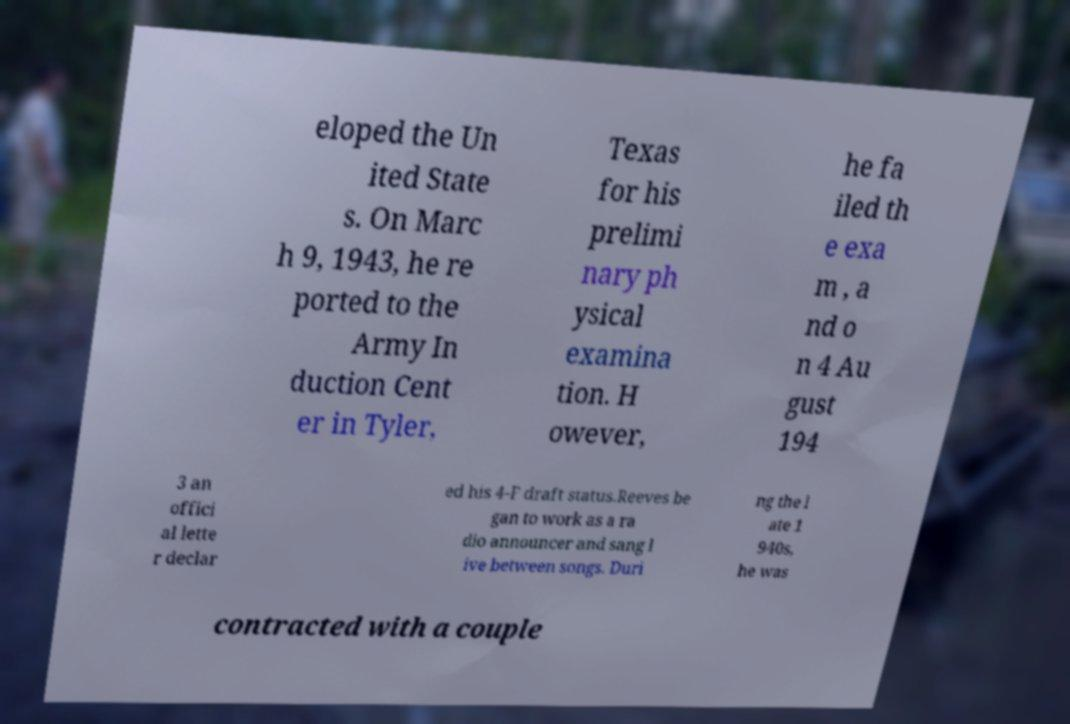I need the written content from this picture converted into text. Can you do that? eloped the Un ited State s. On Marc h 9, 1943, he re ported to the Army In duction Cent er in Tyler, Texas for his prelimi nary ph ysical examina tion. H owever, he fa iled th e exa m , a nd o n 4 Au gust 194 3 an offici al lette r declar ed his 4-F draft status.Reeves be gan to work as a ra dio announcer and sang l ive between songs. Duri ng the l ate 1 940s, he was contracted with a couple 